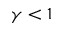<formula> <loc_0><loc_0><loc_500><loc_500>\gamma < 1</formula> 